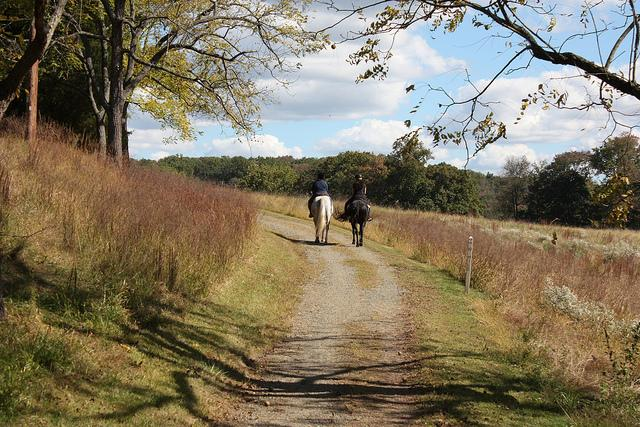What animals are present? horses 